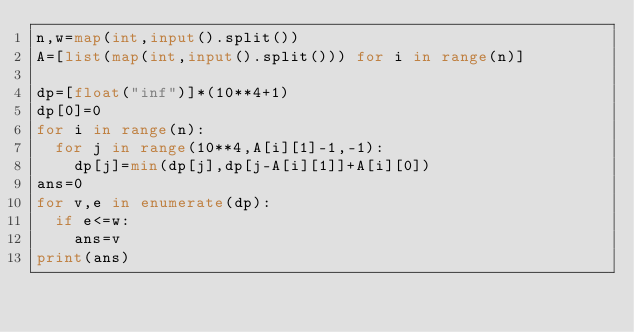<code> <loc_0><loc_0><loc_500><loc_500><_Python_>n,w=map(int,input().split())
A=[list(map(int,input().split())) for i in range(n)]

dp=[float("inf")]*(10**4+1)
dp[0]=0
for i in range(n):
  for j in range(10**4,A[i][1]-1,-1):
    dp[j]=min(dp[j],dp[j-A[i][1]]+A[i][0])
ans=0
for v,e in enumerate(dp):
  if e<=w:
    ans=v
print(ans)
</code> 